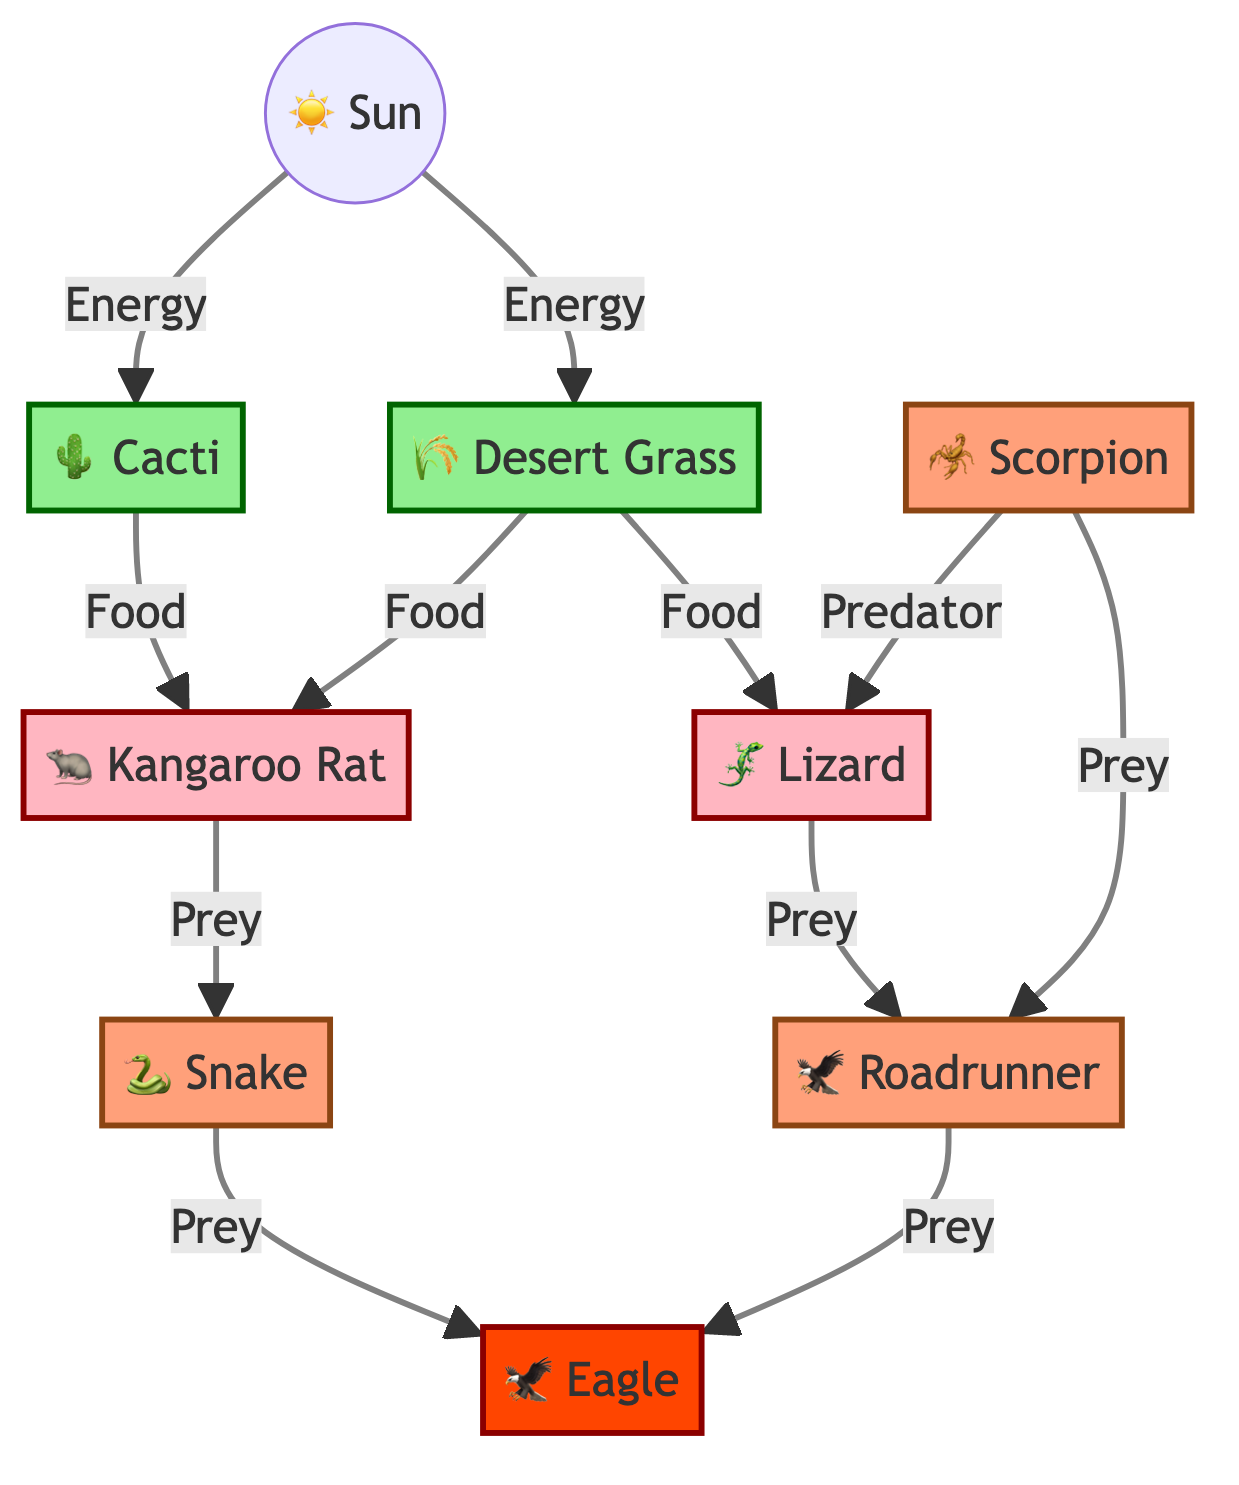What are the producers in this desert food chain? The producers are the organisms that convert sunlight into energy through photosynthesis. In this diagram, the producers are the Cacti and Desert Grass, which are directly connected to the Sun.
Answer: Cacti, Desert Grass How many consumers are present in the desert food chain? Consumers are organisms that eat producers and other consumers. In the diagram, there are three consumers: Kangaroo Rat, Lizard, and Scorpion. These are classified under the consumer category, so we count them.
Answer: 3 Which predator directly preys on the Lizard? The diagram shows that the Scorpion is labeled as a predator and has a direct connection to the Lizard, indicating it preys on it.
Answer: Scorpion What is the apex predator in this desert food chain? The apex predator is the highest level in the food chain with no natural predators. According to the diagram, the Eagle is identified as the apex predator, which preys on both the Snake and the Roadrunner.
Answer: Eagle How do Kangaroo Rats obtain their food in this food chain? The Kangaroo Rats obtain their food from two sources. They can eat both Cacti and Desert Grass, as shown by their connections to these producers in the diagram.
Answer: Cacti, Desert Grass Which organism has the highest energy source in this diagram? In the food chain diagram, the Sun is the primary energy source. All producers derive energy from the Sun, making it the organism with the highest energy source.
Answer: Sun How many direct prey relationships are shown in this food chain? We need to count all the connections labeled as "Prey" in the diagram. Kangaroo Rat has one direct prey relationship (with Snake), Lizard (with Roadrunner), Scorpion (with Lizard and Roadrunner), Snake (with Eagle), and Roadrunner (with Eagle) gives us a total of four unique prey connections.
Answer: 5 Which consumer is preyed upon by the Snake? The diagram clearly shows that the Kangaroo Rat is directly connected to the Snake as its prey, making it the correct answer.
Answer: Kangaroo Rat What type of consumer is the Roadrunner classified as in the food chain? The Roadrunner is identified as a predator in the diagram because it preys on the Lizard, reflecting its role in the food chain, where it is above other consumers but below the apex predator.
Answer: Predator 